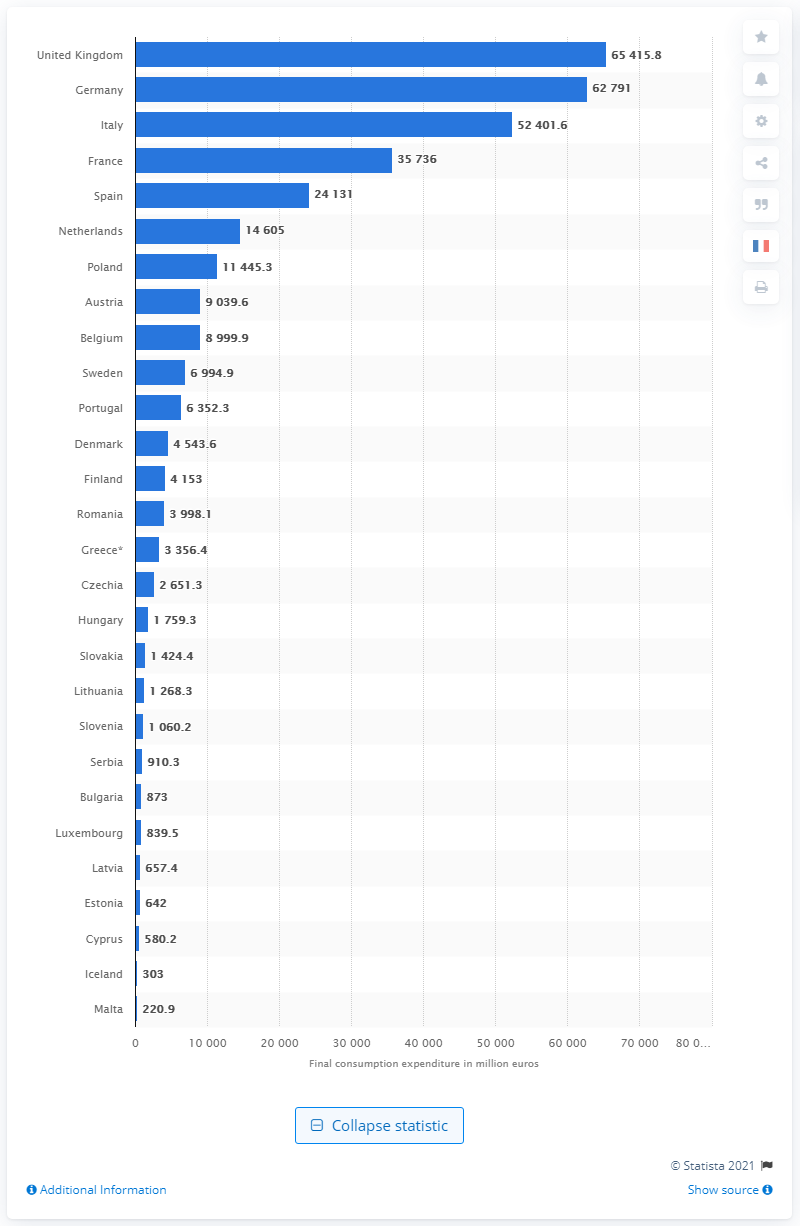Indicate a few pertinent items in this graphic. In 2018, households in the UK spent an estimated 65,415.8 pounds on clothing. 